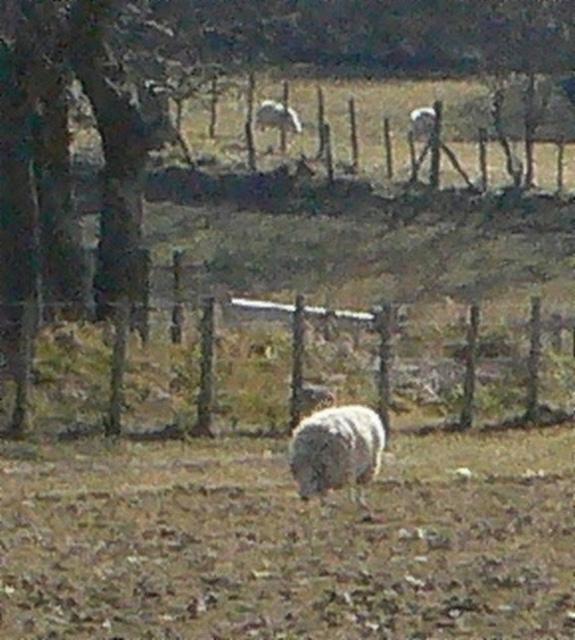How many sheep are in the back?
Give a very brief answer. 2. 